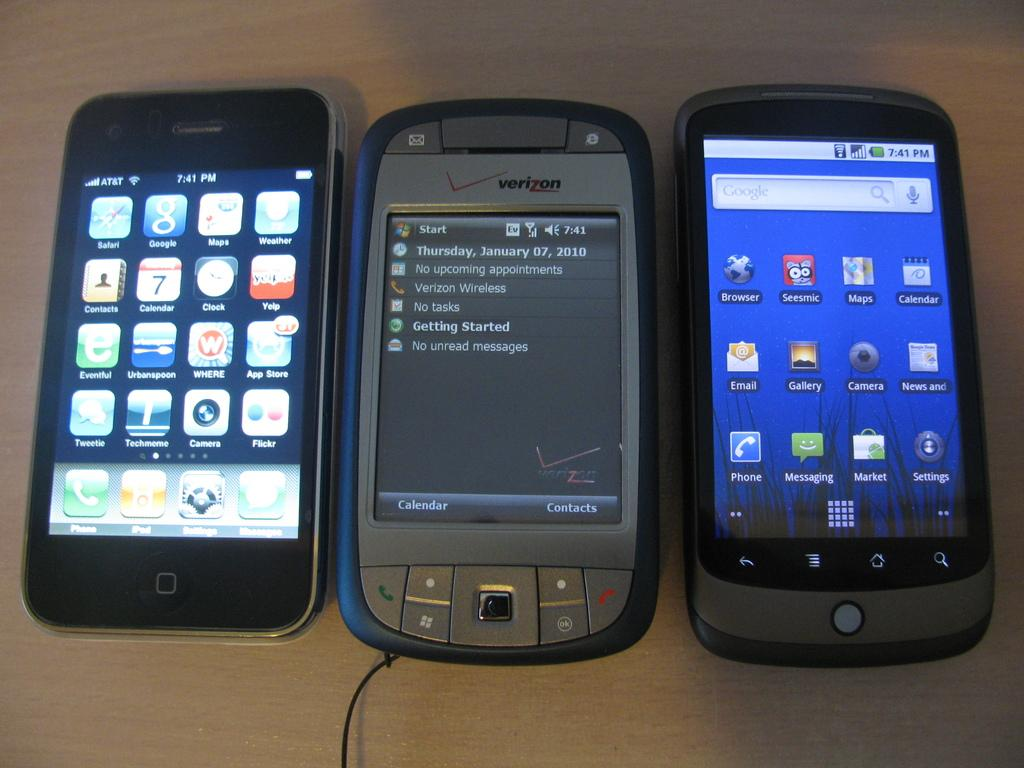<image>
Give a short and clear explanation of the subsequent image. the year 2010 is on the front of the phone 